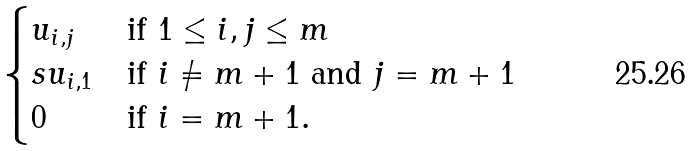<formula> <loc_0><loc_0><loc_500><loc_500>\begin{cases} u _ { i , j } & \text {if } 1 \leq i , j \leq m \\ s u _ { i , 1 } & \text {if } i \neq m + 1 \text { and } j = m + 1 \\ 0 & \text {if } i = m + 1 . \end{cases}</formula> 